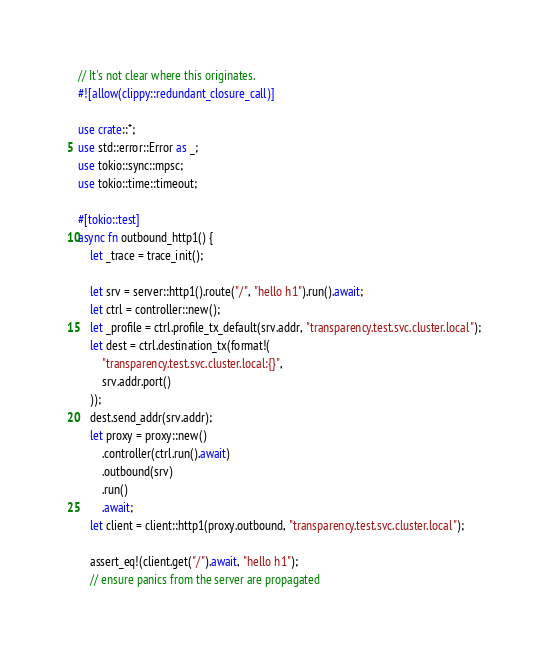Convert code to text. <code><loc_0><loc_0><loc_500><loc_500><_Rust_>// It's not clear where this originates.
#![allow(clippy::redundant_closure_call)]

use crate::*;
use std::error::Error as _;
use tokio::sync::mpsc;
use tokio::time::timeout;

#[tokio::test]
async fn outbound_http1() {
    let _trace = trace_init();

    let srv = server::http1().route("/", "hello h1").run().await;
    let ctrl = controller::new();
    let _profile = ctrl.profile_tx_default(srv.addr, "transparency.test.svc.cluster.local");
    let dest = ctrl.destination_tx(format!(
        "transparency.test.svc.cluster.local:{}",
        srv.addr.port()
    ));
    dest.send_addr(srv.addr);
    let proxy = proxy::new()
        .controller(ctrl.run().await)
        .outbound(srv)
        .run()
        .await;
    let client = client::http1(proxy.outbound, "transparency.test.svc.cluster.local");

    assert_eq!(client.get("/").await, "hello h1");
    // ensure panics from the server are propagated</code> 